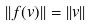<formula> <loc_0><loc_0><loc_500><loc_500>| | f ( v ) | | = | | v | |</formula> 